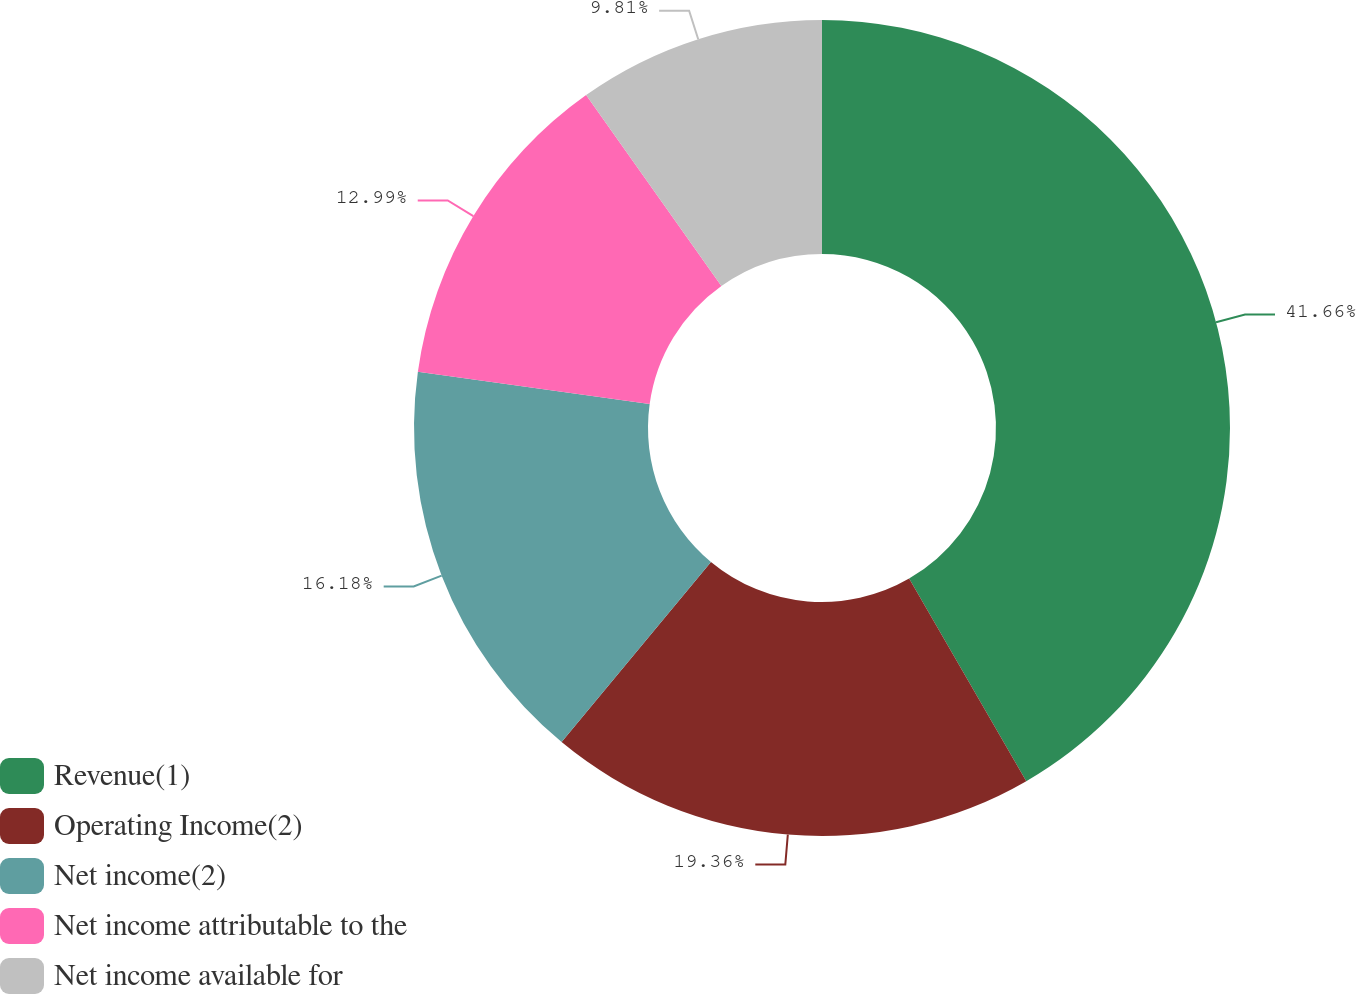<chart> <loc_0><loc_0><loc_500><loc_500><pie_chart><fcel>Revenue(1)<fcel>Operating Income(2)<fcel>Net income(2)<fcel>Net income attributable to the<fcel>Net income available for<nl><fcel>41.65%<fcel>19.36%<fcel>16.18%<fcel>12.99%<fcel>9.81%<nl></chart> 